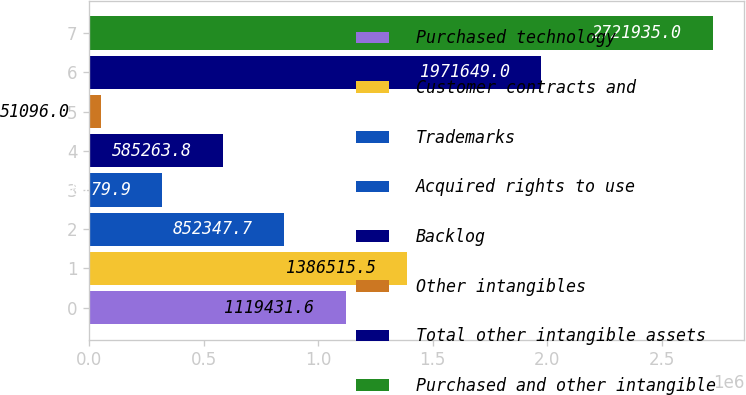Convert chart. <chart><loc_0><loc_0><loc_500><loc_500><bar_chart><fcel>Purchased technology<fcel>Customer contracts and<fcel>Trademarks<fcel>Acquired rights to use<fcel>Backlog<fcel>Other intangibles<fcel>Total other intangible assets<fcel>Purchased and other intangible<nl><fcel>1.11943e+06<fcel>1.38652e+06<fcel>852348<fcel>318180<fcel>585264<fcel>51096<fcel>1.97165e+06<fcel>2.72194e+06<nl></chart> 